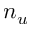Convert formula to latex. <formula><loc_0><loc_0><loc_500><loc_500>n _ { u }</formula> 